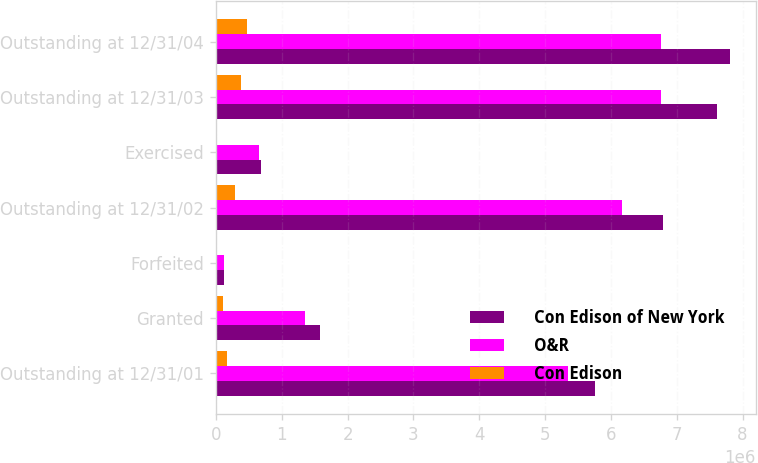Convert chart to OTSL. <chart><loc_0><loc_0><loc_500><loc_500><stacked_bar_chart><ecel><fcel>Outstanding at 12/31/01<fcel>Granted<fcel>Forfeited<fcel>Outstanding at 12/31/02<fcel>Exercised<fcel>Outstanding at 12/31/03<fcel>Outstanding at 12/31/04<nl><fcel>Con Edison of New York<fcel>5.75465e+06<fcel>1.58435e+06<fcel>127450<fcel>6.79765e+06<fcel>692175<fcel>7.61718e+06<fcel>7.80918e+06<nl><fcel>O&R<fcel>5.34645e+06<fcel>1.34985e+06<fcel>116950<fcel>6.16615e+06<fcel>660425<fcel>6.75343e+06<fcel>6.75925e+06<nl><fcel>Con Edison<fcel>174000<fcel>113000<fcel>2000<fcel>285000<fcel>9500<fcel>388500<fcel>465000<nl></chart> 